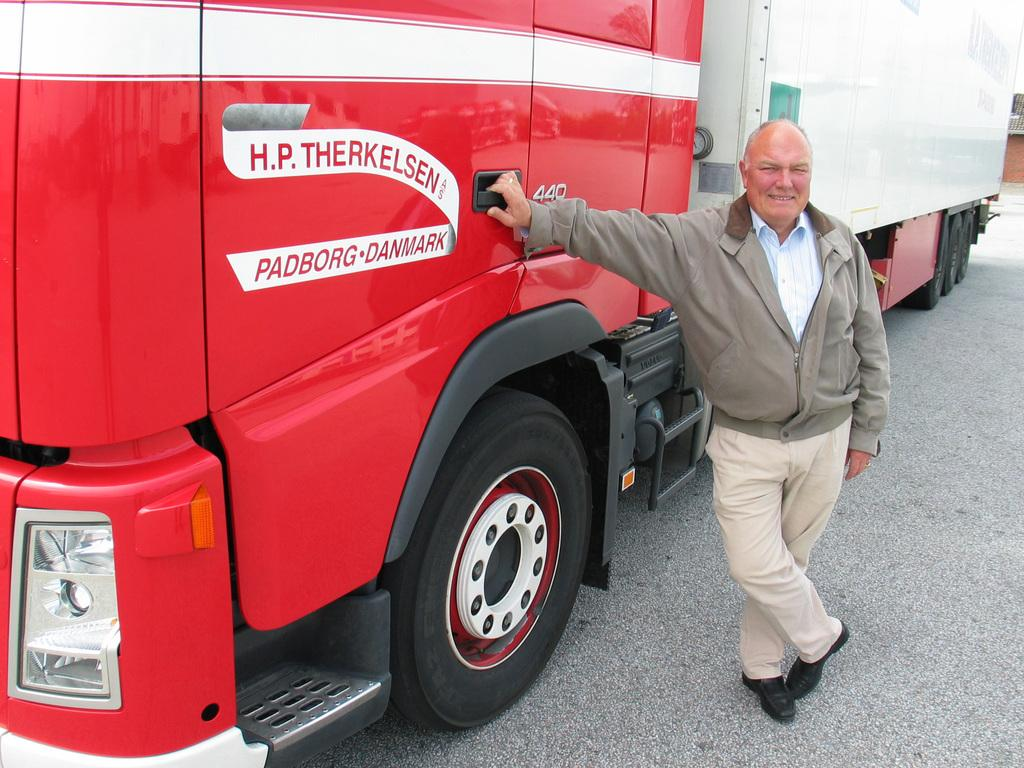What is the main subject in the image? There is a man standing in the image. What else can be seen in the image besides the man? There is a vehicle in the image. What is the setting of the image? There is a road at the bottom of the image. What is the man writing on the road in the image? There is no indication that the man is writing on the road in the image. 